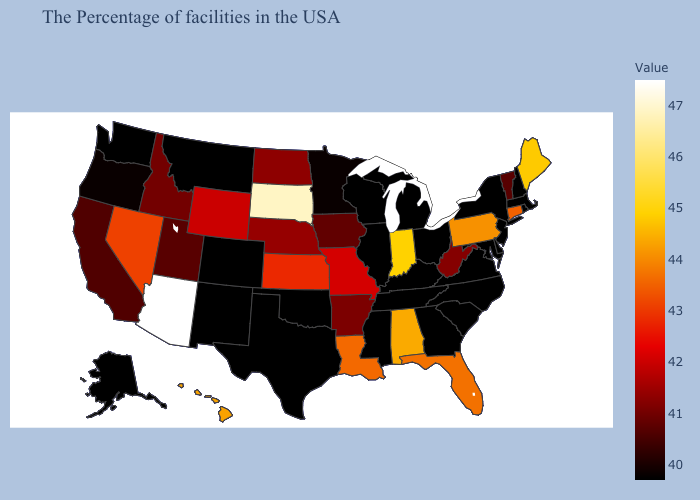Does the map have missing data?
Quick response, please. No. Which states have the highest value in the USA?
Be succinct. Arizona. Does Iowa have the highest value in the USA?
Keep it brief. No. Does Illinois have the lowest value in the USA?
Write a very short answer. Yes. Among the states that border North Dakota , does Montana have the lowest value?
Write a very short answer. Yes. 